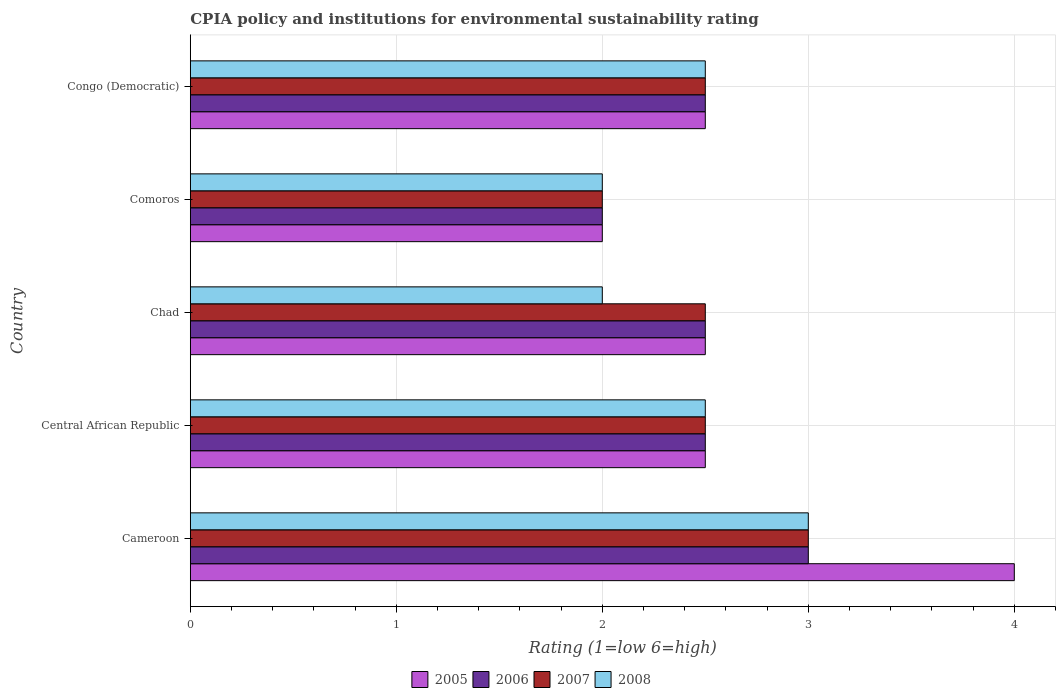How many bars are there on the 3rd tick from the top?
Offer a terse response. 4. How many bars are there on the 4th tick from the bottom?
Provide a succinct answer. 4. What is the label of the 3rd group of bars from the top?
Keep it short and to the point. Chad. In which country was the CPIA rating in 2007 maximum?
Ensure brevity in your answer.  Cameroon. In which country was the CPIA rating in 2005 minimum?
Keep it short and to the point. Comoros. What is the difference between the CPIA rating in 2007 in Central African Republic and that in Congo (Democratic)?
Offer a very short reply. 0. What is the average CPIA rating in 2008 per country?
Your response must be concise. 2.4. What is the difference between the CPIA rating in 2006 and CPIA rating in 2008 in Congo (Democratic)?
Your response must be concise. 0. What is the ratio of the CPIA rating in 2008 in Chad to that in Comoros?
Give a very brief answer. 1. Is the CPIA rating in 2008 in Cameroon less than that in Congo (Democratic)?
Provide a short and direct response. No. In how many countries, is the CPIA rating in 2008 greater than the average CPIA rating in 2008 taken over all countries?
Your response must be concise. 3. Is it the case that in every country, the sum of the CPIA rating in 2007 and CPIA rating in 2006 is greater than the sum of CPIA rating in 2005 and CPIA rating in 2008?
Your answer should be compact. No. What does the 2nd bar from the bottom in Chad represents?
Keep it short and to the point. 2006. Is it the case that in every country, the sum of the CPIA rating in 2007 and CPIA rating in 2008 is greater than the CPIA rating in 2006?
Keep it short and to the point. Yes. How many countries are there in the graph?
Offer a terse response. 5. What is the difference between two consecutive major ticks on the X-axis?
Provide a short and direct response. 1. Does the graph contain any zero values?
Keep it short and to the point. No. Does the graph contain grids?
Keep it short and to the point. Yes. What is the title of the graph?
Your response must be concise. CPIA policy and institutions for environmental sustainability rating. Does "1984" appear as one of the legend labels in the graph?
Offer a terse response. No. What is the label or title of the X-axis?
Your answer should be compact. Rating (1=low 6=high). What is the label or title of the Y-axis?
Ensure brevity in your answer.  Country. What is the Rating (1=low 6=high) of 2005 in Cameroon?
Make the answer very short. 4. What is the Rating (1=low 6=high) of 2007 in Cameroon?
Provide a short and direct response. 3. What is the Rating (1=low 6=high) of 2008 in Cameroon?
Your answer should be compact. 3. What is the Rating (1=low 6=high) of 2007 in Central African Republic?
Offer a terse response. 2.5. What is the Rating (1=low 6=high) in 2008 in Central African Republic?
Make the answer very short. 2.5. What is the Rating (1=low 6=high) of 2006 in Chad?
Make the answer very short. 2.5. What is the Rating (1=low 6=high) in 2007 in Chad?
Offer a terse response. 2.5. What is the Rating (1=low 6=high) of 2008 in Chad?
Your response must be concise. 2. What is the Rating (1=low 6=high) in 2005 in Comoros?
Your response must be concise. 2. What is the Rating (1=low 6=high) in 2006 in Comoros?
Make the answer very short. 2. What is the Rating (1=low 6=high) in 2008 in Comoros?
Offer a terse response. 2. What is the Rating (1=low 6=high) in 2005 in Congo (Democratic)?
Make the answer very short. 2.5. What is the Rating (1=low 6=high) in 2006 in Congo (Democratic)?
Ensure brevity in your answer.  2.5. What is the Rating (1=low 6=high) in 2007 in Congo (Democratic)?
Your answer should be very brief. 2.5. What is the Rating (1=low 6=high) of 2008 in Congo (Democratic)?
Provide a succinct answer. 2.5. Across all countries, what is the maximum Rating (1=low 6=high) in 2005?
Provide a short and direct response. 4. Across all countries, what is the maximum Rating (1=low 6=high) of 2006?
Your response must be concise. 3. Across all countries, what is the maximum Rating (1=low 6=high) of 2007?
Give a very brief answer. 3. Across all countries, what is the maximum Rating (1=low 6=high) in 2008?
Your answer should be very brief. 3. Across all countries, what is the minimum Rating (1=low 6=high) of 2005?
Your answer should be compact. 2. What is the total Rating (1=low 6=high) in 2006 in the graph?
Your response must be concise. 12.5. What is the total Rating (1=low 6=high) in 2007 in the graph?
Give a very brief answer. 12.5. What is the total Rating (1=low 6=high) in 2008 in the graph?
Ensure brevity in your answer.  12. What is the difference between the Rating (1=low 6=high) in 2005 in Cameroon and that in Central African Republic?
Your answer should be compact. 1.5. What is the difference between the Rating (1=low 6=high) in 2006 in Cameroon and that in Central African Republic?
Your answer should be very brief. 0.5. What is the difference between the Rating (1=low 6=high) in 2008 in Cameroon and that in Central African Republic?
Your answer should be compact. 0.5. What is the difference between the Rating (1=low 6=high) in 2005 in Cameroon and that in Chad?
Make the answer very short. 1.5. What is the difference between the Rating (1=low 6=high) in 2007 in Cameroon and that in Chad?
Give a very brief answer. 0.5. What is the difference between the Rating (1=low 6=high) of 2008 in Cameroon and that in Chad?
Provide a short and direct response. 1. What is the difference between the Rating (1=low 6=high) in 2005 in Cameroon and that in Comoros?
Your answer should be compact. 2. What is the difference between the Rating (1=low 6=high) in 2006 in Cameroon and that in Comoros?
Make the answer very short. 1. What is the difference between the Rating (1=low 6=high) in 2008 in Cameroon and that in Comoros?
Your answer should be compact. 1. What is the difference between the Rating (1=low 6=high) in 2007 in Cameroon and that in Congo (Democratic)?
Offer a very short reply. 0.5. What is the difference between the Rating (1=low 6=high) in 2005 in Central African Republic and that in Chad?
Make the answer very short. 0. What is the difference between the Rating (1=low 6=high) in 2006 in Central African Republic and that in Chad?
Provide a succinct answer. 0. What is the difference between the Rating (1=low 6=high) of 2007 in Central African Republic and that in Chad?
Provide a short and direct response. 0. What is the difference between the Rating (1=low 6=high) in 2008 in Central African Republic and that in Chad?
Make the answer very short. 0.5. What is the difference between the Rating (1=low 6=high) in 2006 in Central African Republic and that in Comoros?
Your answer should be compact. 0.5. What is the difference between the Rating (1=low 6=high) of 2007 in Central African Republic and that in Comoros?
Offer a terse response. 0.5. What is the difference between the Rating (1=low 6=high) in 2005 in Central African Republic and that in Congo (Democratic)?
Provide a succinct answer. 0. What is the difference between the Rating (1=low 6=high) of 2007 in Central African Republic and that in Congo (Democratic)?
Offer a very short reply. 0. What is the difference between the Rating (1=low 6=high) in 2006 in Chad and that in Comoros?
Offer a terse response. 0.5. What is the difference between the Rating (1=low 6=high) in 2008 in Chad and that in Comoros?
Your answer should be compact. 0. What is the difference between the Rating (1=low 6=high) of 2006 in Chad and that in Congo (Democratic)?
Ensure brevity in your answer.  0. What is the difference between the Rating (1=low 6=high) of 2008 in Chad and that in Congo (Democratic)?
Provide a short and direct response. -0.5. What is the difference between the Rating (1=low 6=high) of 2005 in Comoros and that in Congo (Democratic)?
Keep it short and to the point. -0.5. What is the difference between the Rating (1=low 6=high) of 2006 in Comoros and that in Congo (Democratic)?
Give a very brief answer. -0.5. What is the difference between the Rating (1=low 6=high) of 2005 in Cameroon and the Rating (1=low 6=high) of 2006 in Central African Republic?
Ensure brevity in your answer.  1.5. What is the difference between the Rating (1=low 6=high) of 2005 in Cameroon and the Rating (1=low 6=high) of 2007 in Central African Republic?
Your response must be concise. 1.5. What is the difference between the Rating (1=low 6=high) of 2005 in Cameroon and the Rating (1=low 6=high) of 2008 in Central African Republic?
Your answer should be compact. 1.5. What is the difference between the Rating (1=low 6=high) of 2006 in Cameroon and the Rating (1=low 6=high) of 2007 in Central African Republic?
Your answer should be compact. 0.5. What is the difference between the Rating (1=low 6=high) in 2005 in Cameroon and the Rating (1=low 6=high) in 2007 in Chad?
Keep it short and to the point. 1.5. What is the difference between the Rating (1=low 6=high) of 2005 in Cameroon and the Rating (1=low 6=high) of 2008 in Chad?
Provide a short and direct response. 2. What is the difference between the Rating (1=low 6=high) of 2006 in Cameroon and the Rating (1=low 6=high) of 2008 in Chad?
Keep it short and to the point. 1. What is the difference between the Rating (1=low 6=high) in 2005 in Cameroon and the Rating (1=low 6=high) in 2006 in Comoros?
Ensure brevity in your answer.  2. What is the difference between the Rating (1=low 6=high) of 2006 in Cameroon and the Rating (1=low 6=high) of 2007 in Comoros?
Your answer should be very brief. 1. What is the difference between the Rating (1=low 6=high) of 2006 in Cameroon and the Rating (1=low 6=high) of 2008 in Comoros?
Ensure brevity in your answer.  1. What is the difference between the Rating (1=low 6=high) in 2007 in Cameroon and the Rating (1=low 6=high) in 2008 in Congo (Democratic)?
Offer a very short reply. 0.5. What is the difference between the Rating (1=low 6=high) in 2005 in Central African Republic and the Rating (1=low 6=high) in 2006 in Chad?
Your response must be concise. 0. What is the difference between the Rating (1=low 6=high) of 2006 in Central African Republic and the Rating (1=low 6=high) of 2007 in Chad?
Provide a succinct answer. 0. What is the difference between the Rating (1=low 6=high) in 2007 in Central African Republic and the Rating (1=low 6=high) in 2008 in Chad?
Give a very brief answer. 0.5. What is the difference between the Rating (1=low 6=high) in 2006 in Central African Republic and the Rating (1=low 6=high) in 2007 in Comoros?
Provide a succinct answer. 0.5. What is the difference between the Rating (1=low 6=high) of 2006 in Central African Republic and the Rating (1=low 6=high) of 2008 in Comoros?
Give a very brief answer. 0.5. What is the difference between the Rating (1=low 6=high) of 2005 in Central African Republic and the Rating (1=low 6=high) of 2007 in Congo (Democratic)?
Keep it short and to the point. 0. What is the difference between the Rating (1=low 6=high) of 2005 in Central African Republic and the Rating (1=low 6=high) of 2008 in Congo (Democratic)?
Provide a short and direct response. 0. What is the difference between the Rating (1=low 6=high) of 2006 in Central African Republic and the Rating (1=low 6=high) of 2008 in Congo (Democratic)?
Your response must be concise. 0. What is the difference between the Rating (1=low 6=high) in 2005 in Chad and the Rating (1=low 6=high) in 2007 in Comoros?
Offer a very short reply. 0.5. What is the difference between the Rating (1=low 6=high) in 2005 in Chad and the Rating (1=low 6=high) in 2008 in Comoros?
Give a very brief answer. 0.5. What is the difference between the Rating (1=low 6=high) in 2006 in Chad and the Rating (1=low 6=high) in 2008 in Comoros?
Keep it short and to the point. 0.5. What is the difference between the Rating (1=low 6=high) of 2005 in Chad and the Rating (1=low 6=high) of 2008 in Congo (Democratic)?
Offer a terse response. 0. What is the difference between the Rating (1=low 6=high) in 2007 in Chad and the Rating (1=low 6=high) in 2008 in Congo (Democratic)?
Provide a short and direct response. 0. What is the difference between the Rating (1=low 6=high) in 2005 in Comoros and the Rating (1=low 6=high) in 2006 in Congo (Democratic)?
Give a very brief answer. -0.5. What is the difference between the Rating (1=low 6=high) of 2005 in Comoros and the Rating (1=low 6=high) of 2007 in Congo (Democratic)?
Your response must be concise. -0.5. What is the difference between the Rating (1=low 6=high) in 2006 in Comoros and the Rating (1=low 6=high) in 2007 in Congo (Democratic)?
Give a very brief answer. -0.5. What is the difference between the Rating (1=low 6=high) in 2006 in Comoros and the Rating (1=low 6=high) in 2008 in Congo (Democratic)?
Provide a short and direct response. -0.5. What is the average Rating (1=low 6=high) of 2005 per country?
Your answer should be very brief. 2.7. What is the average Rating (1=low 6=high) in 2006 per country?
Give a very brief answer. 2.5. What is the average Rating (1=low 6=high) of 2008 per country?
Give a very brief answer. 2.4. What is the difference between the Rating (1=low 6=high) of 2005 and Rating (1=low 6=high) of 2007 in Cameroon?
Make the answer very short. 1. What is the difference between the Rating (1=low 6=high) of 2005 and Rating (1=low 6=high) of 2008 in Cameroon?
Ensure brevity in your answer.  1. What is the difference between the Rating (1=low 6=high) in 2005 and Rating (1=low 6=high) in 2007 in Central African Republic?
Your answer should be very brief. 0. What is the difference between the Rating (1=low 6=high) in 2005 and Rating (1=low 6=high) in 2008 in Central African Republic?
Your answer should be compact. 0. What is the difference between the Rating (1=low 6=high) of 2006 and Rating (1=low 6=high) of 2007 in Central African Republic?
Make the answer very short. 0. What is the difference between the Rating (1=low 6=high) in 2006 and Rating (1=low 6=high) in 2008 in Central African Republic?
Your answer should be very brief. 0. What is the difference between the Rating (1=low 6=high) in 2005 and Rating (1=low 6=high) in 2007 in Chad?
Offer a terse response. 0. What is the difference between the Rating (1=low 6=high) in 2006 and Rating (1=low 6=high) in 2007 in Chad?
Provide a short and direct response. 0. What is the difference between the Rating (1=low 6=high) of 2005 and Rating (1=low 6=high) of 2008 in Comoros?
Keep it short and to the point. 0. What is the difference between the Rating (1=low 6=high) of 2005 and Rating (1=low 6=high) of 2006 in Congo (Democratic)?
Make the answer very short. 0. What is the difference between the Rating (1=low 6=high) in 2005 and Rating (1=low 6=high) in 2007 in Congo (Democratic)?
Your answer should be very brief. 0. What is the difference between the Rating (1=low 6=high) of 2005 and Rating (1=low 6=high) of 2008 in Congo (Democratic)?
Provide a short and direct response. 0. What is the difference between the Rating (1=low 6=high) of 2006 and Rating (1=low 6=high) of 2008 in Congo (Democratic)?
Keep it short and to the point. 0. What is the difference between the Rating (1=low 6=high) of 2007 and Rating (1=low 6=high) of 2008 in Congo (Democratic)?
Provide a short and direct response. 0. What is the ratio of the Rating (1=low 6=high) of 2005 in Cameroon to that in Central African Republic?
Provide a succinct answer. 1.6. What is the ratio of the Rating (1=low 6=high) of 2007 in Cameroon to that in Central African Republic?
Provide a short and direct response. 1.2. What is the ratio of the Rating (1=low 6=high) of 2005 in Cameroon to that in Chad?
Your response must be concise. 1.6. What is the ratio of the Rating (1=low 6=high) of 2006 in Cameroon to that in Chad?
Give a very brief answer. 1.2. What is the ratio of the Rating (1=low 6=high) in 2008 in Cameroon to that in Chad?
Keep it short and to the point. 1.5. What is the ratio of the Rating (1=low 6=high) in 2007 in Cameroon to that in Comoros?
Your response must be concise. 1.5. What is the ratio of the Rating (1=low 6=high) of 2007 in Cameroon to that in Congo (Democratic)?
Provide a short and direct response. 1.2. What is the ratio of the Rating (1=low 6=high) of 2005 in Central African Republic to that in Chad?
Keep it short and to the point. 1. What is the ratio of the Rating (1=low 6=high) in 2006 in Central African Republic to that in Chad?
Make the answer very short. 1. What is the ratio of the Rating (1=low 6=high) of 2007 in Central African Republic to that in Chad?
Make the answer very short. 1. What is the ratio of the Rating (1=low 6=high) in 2006 in Central African Republic to that in Comoros?
Make the answer very short. 1.25. What is the ratio of the Rating (1=low 6=high) of 2007 in Central African Republic to that in Comoros?
Make the answer very short. 1.25. What is the ratio of the Rating (1=low 6=high) of 2008 in Central African Republic to that in Comoros?
Your answer should be very brief. 1.25. What is the ratio of the Rating (1=low 6=high) of 2005 in Central African Republic to that in Congo (Democratic)?
Give a very brief answer. 1. What is the ratio of the Rating (1=low 6=high) of 2006 in Central African Republic to that in Congo (Democratic)?
Ensure brevity in your answer.  1. What is the ratio of the Rating (1=low 6=high) in 2007 in Central African Republic to that in Congo (Democratic)?
Your response must be concise. 1. What is the ratio of the Rating (1=low 6=high) of 2008 in Central African Republic to that in Congo (Democratic)?
Ensure brevity in your answer.  1. What is the ratio of the Rating (1=low 6=high) in 2005 in Chad to that in Comoros?
Ensure brevity in your answer.  1.25. What is the ratio of the Rating (1=low 6=high) in 2005 in Chad to that in Congo (Democratic)?
Ensure brevity in your answer.  1. What is the ratio of the Rating (1=low 6=high) in 2007 in Comoros to that in Congo (Democratic)?
Provide a succinct answer. 0.8. What is the ratio of the Rating (1=low 6=high) of 2008 in Comoros to that in Congo (Democratic)?
Your response must be concise. 0.8. What is the difference between the highest and the second highest Rating (1=low 6=high) of 2006?
Ensure brevity in your answer.  0.5. What is the difference between the highest and the second highest Rating (1=low 6=high) of 2007?
Your answer should be very brief. 0.5. What is the difference between the highest and the second highest Rating (1=low 6=high) of 2008?
Provide a short and direct response. 0.5. What is the difference between the highest and the lowest Rating (1=low 6=high) of 2005?
Offer a terse response. 2. What is the difference between the highest and the lowest Rating (1=low 6=high) in 2006?
Provide a succinct answer. 1. What is the difference between the highest and the lowest Rating (1=low 6=high) of 2007?
Keep it short and to the point. 1. 